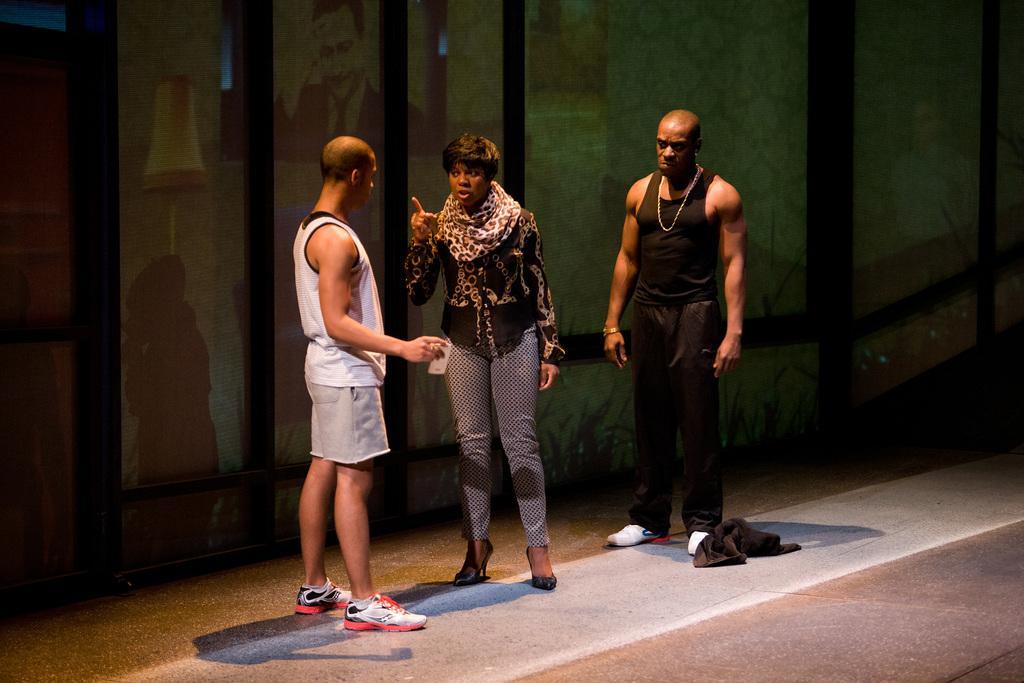Could you give a brief overview of what you see in this image? In this image we can see three persons are standing on the floor and we can see pictures of persons on the glasses and there is a cloth on the floor. 